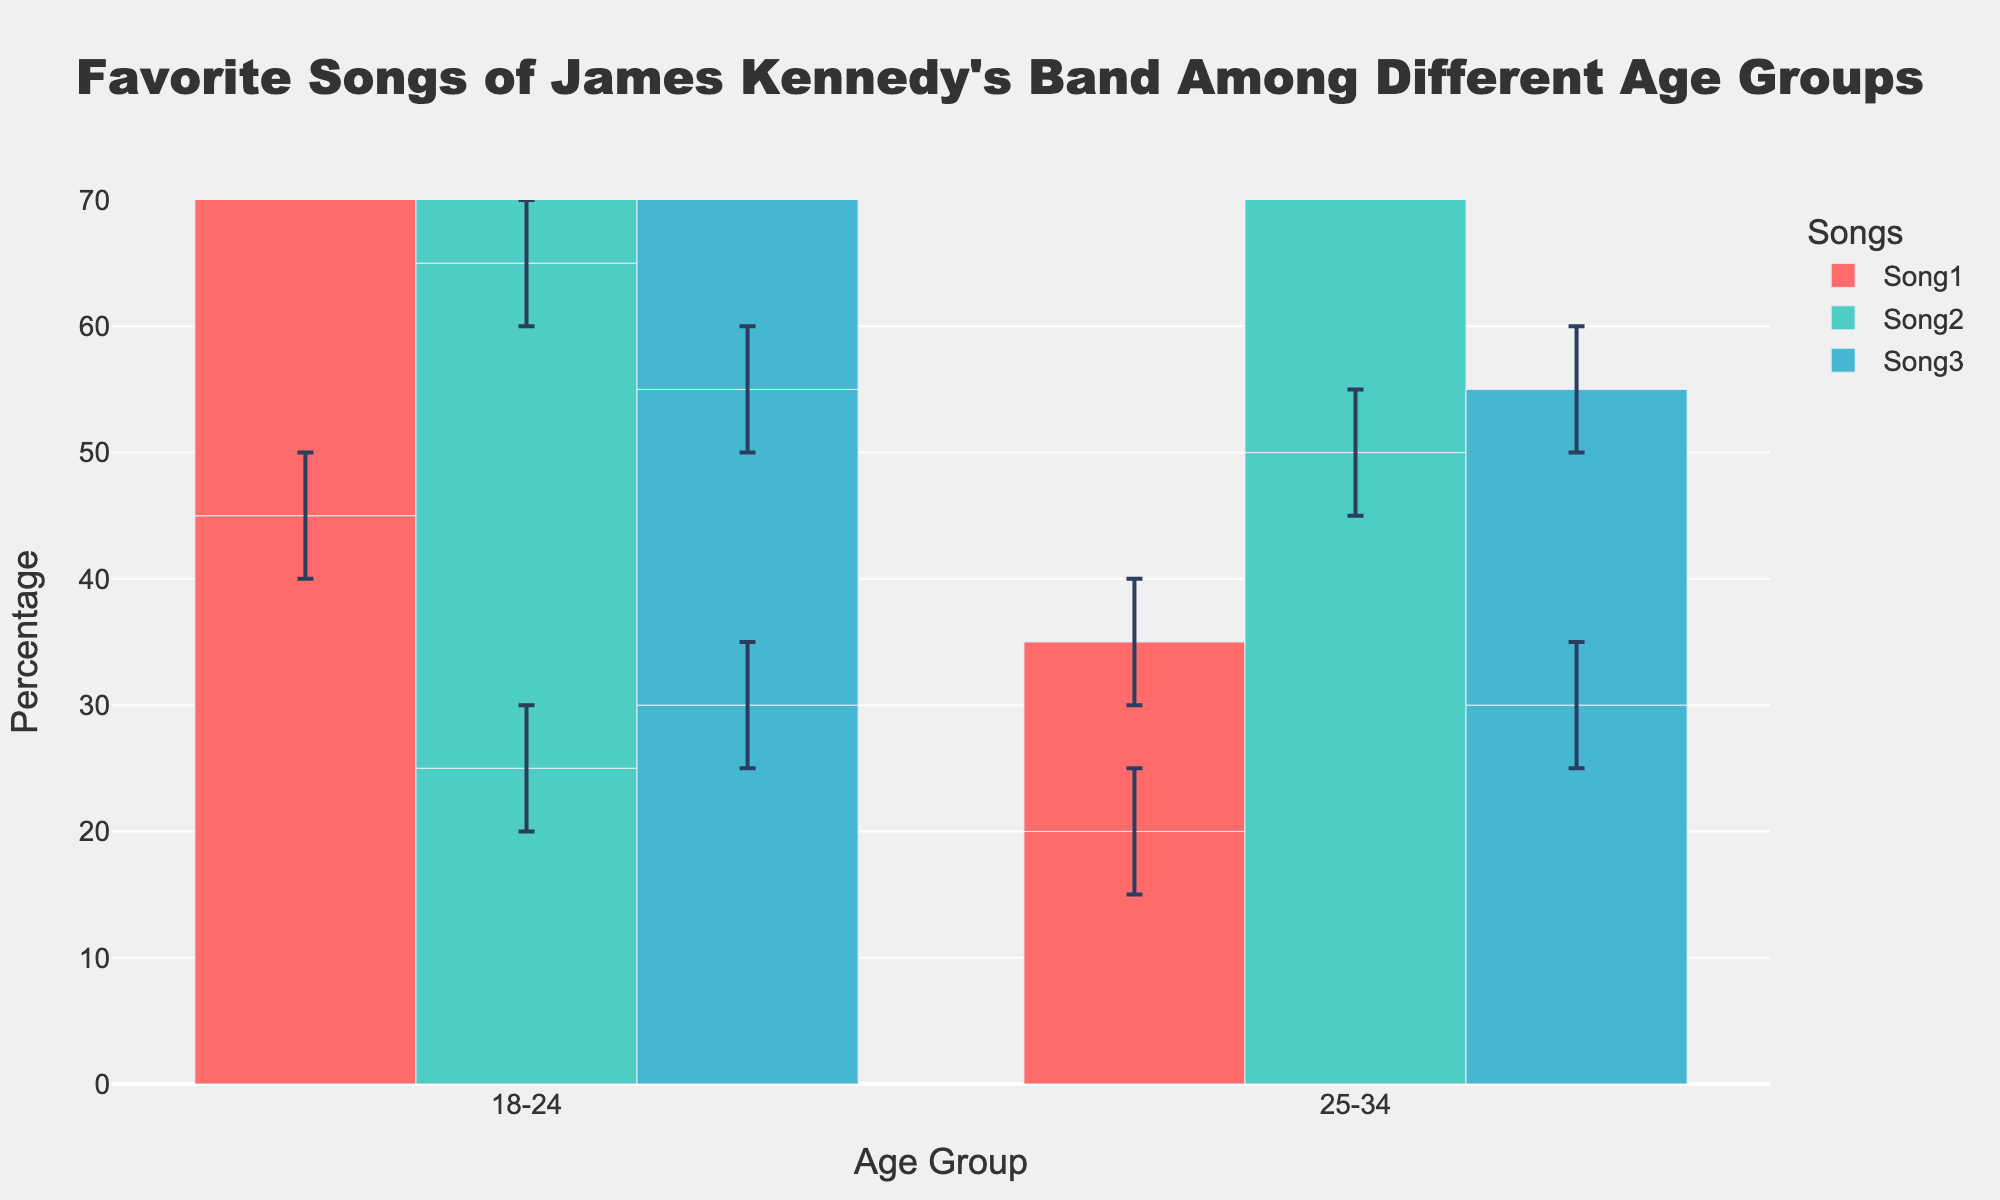What's the title of the plot? The title of the plot is displayed at the top center of the figure. By looking at the plot, we can see: "Favorite Songs of James Kennedy's Band Among Different Age Groups".
Answer: Favorite Songs of James Kennedy's Band Among Different Age Groups Which age group has the highest mean percentage preference for Song2? This can be determined by identifying the age group bar for Song2 with the highest height. According to the plot, the 55+ age group has the highest mean percentage for Song2 at 60%.
Answer: 55+ What is the range of percentages for Song3 among the 18-24 age group? The range is calculated by subtracting the Lower Confidence Interval from the Upper Confidence Interval for this subset. For the 18-24 age group and Song3, these values are from 25% to 35%. Thus, the range is 35% - 25%.
Answer: 10% Which song has the lowest mean percentage in the 55+ age group? By examining the bars for the 55+ age group, we see that Song1 has the shortest bar at 15%.
Answer: Song1 How does the preference for Song1 among the 25-34 age group compare to that of the 35-44 age group? To compare, observe the heights of the bars for Song1 in both age groups. The 25-34 age group has a preference of 35%, while the 35-44 age group has a preference of 30%. The 25-34 group has a higher preference.
Answer: 25-34 age group has a higher preference What is the average mean percentage for Song2 across all age groups? The mean percentages for Song2 are 25% (18-24), 40% (25-34), 45% (35-44), 50% (45-54), and 60% (55+). Adding these together (25 + 40 + 45 + 50 + 60) equals 220, divided by 5 gives an average of 44%.
Answer: 44% What age group shows the greatest spread (difference between upper and lower CI) for their preference for Song1? The spread is calculated by subtracting the Lower CI from the Upper CI for each age group. The greatest spread is where this value is highest. For Song1, the spreads are: 10% (18-24), 10% (25-34), 10% (35-44), 10% (45-54), and 10% (55+). All spreads are equal.
Answer: All age groups Which song's preference remains most stable across different age groups (based on the width of the error bars)? By assessing the widths of error bars for each song across all age groups, a song with smaller error bars indicates more stability. Song2 has comparatively smaller error bars across age groups versus Song1 and Song3, indicating it is the most stable.
Answer: Song2 